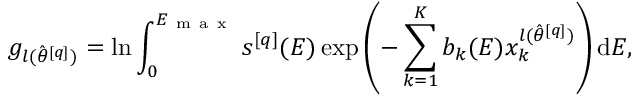Convert formula to latex. <formula><loc_0><loc_0><loc_500><loc_500>g _ { l ( \hat { \theta } ^ { [ q ] } ) } = \ln \int _ { 0 } ^ { E _ { m a x } } s ^ { [ q ] } ( E ) \exp \left ( - \sum _ { k = 1 } ^ { K } b _ { k } ( E ) x _ { k } ^ { l ( \hat { \theta } ^ { [ q ] } ) } \right ) d E ,</formula> 